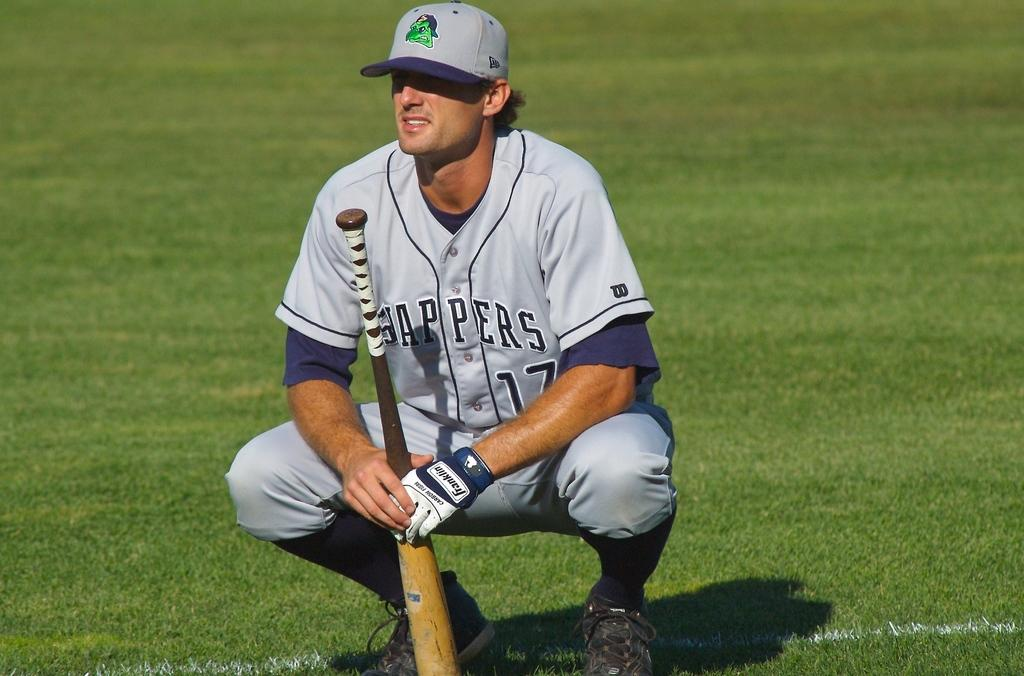<image>
Summarize the visual content of the image. a person wearing a jersey that has the number 17 on it 